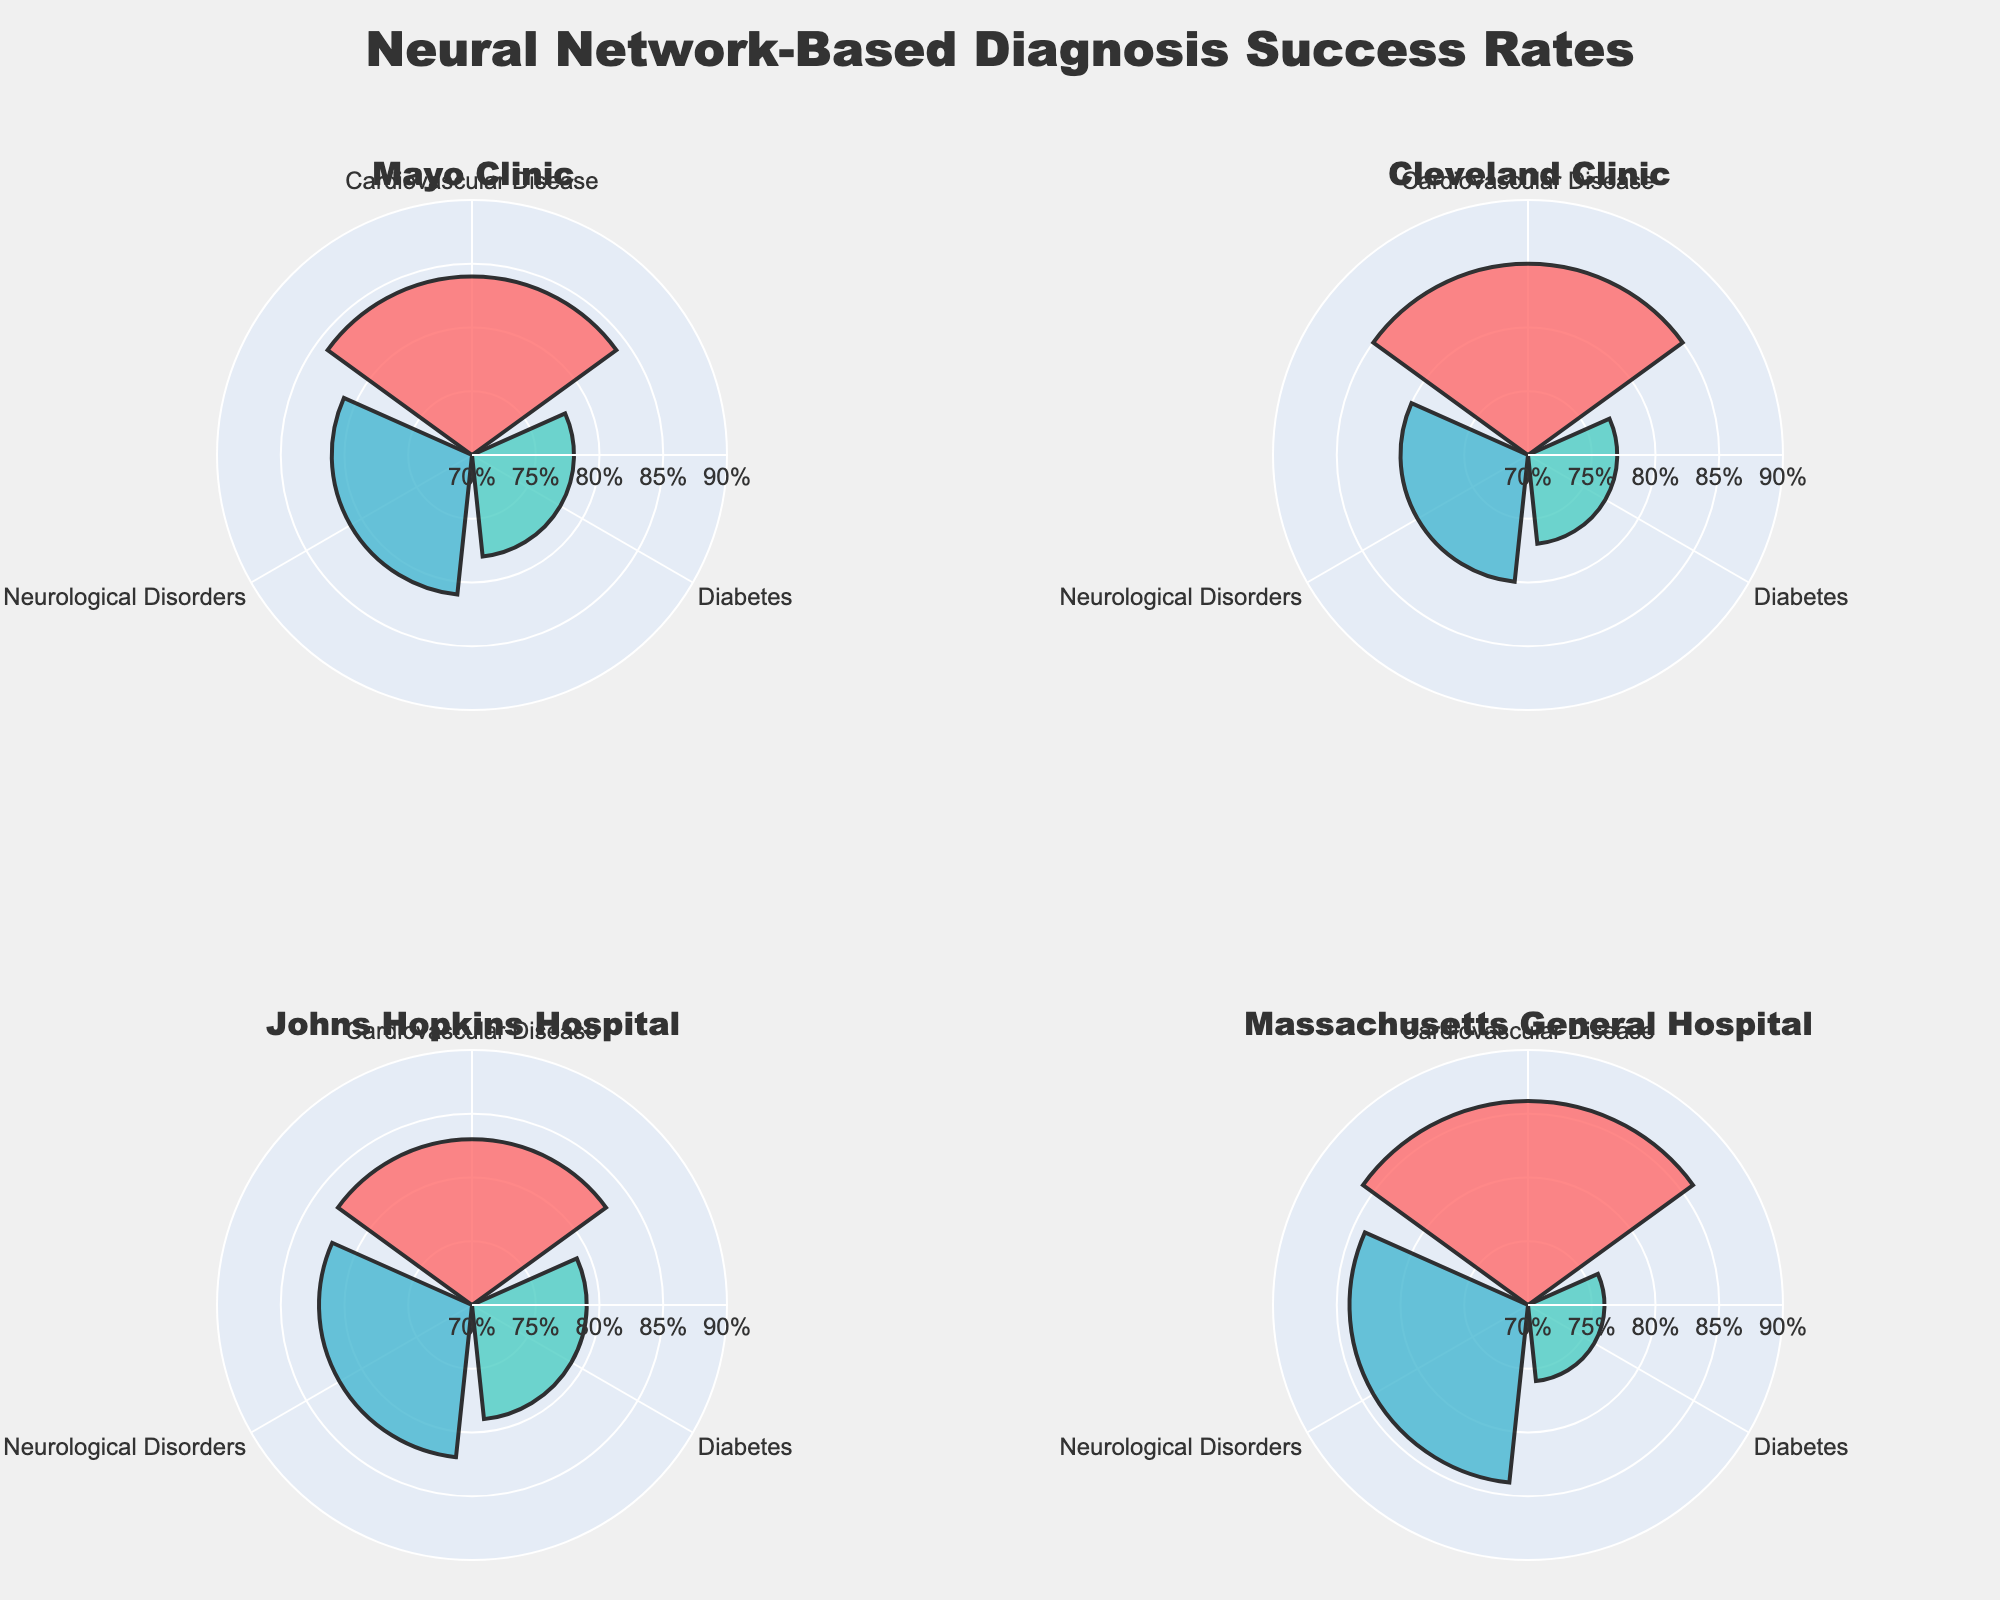What is the success rate of neural network-based diagnosis for Cardiovascular Disease at Mayo Clinic? To find the success rate, locate the Mayo Clinic subplot and see that the Cardiovascular Disease slice extends to the 84% mark on the radial axis.
Answer: 84% Which medical facility has the highest success rate for diagnosing Neurological Disorders? Compare the success rates for Neurological Disorders across all subplots and identify that Massachusetts General Hospital has the highest rate extending to 84%.
Answer: Massachusetts General Hospital Between Mayo Clinic and Cleveland Clinic, which has a higher success rate for diagnosing Diabetes, and by how much? Look at the Diabetes success rates in the subplots for Mayo Clinic and Cleveland Clinic. Mayo Clinic has a 78% success rate while Cleveland Clinic has 77%. The difference is 1%.
Answer: Mayo Clinic, by 1% What is the average success rate for Cardiovascular Disease across all medical facilities? Sum the success rates for Cardiovascular Disease across all subplots: 84%, 85%, 83%, 86%. The total is 338%. Divide by 4 to get the average: 338% / 4 = 84.5%.
Answer: 84.5% How does the success rate for Neurological Disorders at Johns Hopkins Hospital compare to that at Mayo Clinic? Compare the lengths of the Neurological Disorders slices for both Johns Hopkins Hospital (82%) and Mayo Clinic (81%). Johns Hopkins Hospital has a higher rate by 1%.
Answer: Johns Hopkins Hospital is higher by 1% For which condition is the success rate the lowest at Massachusetts General Hospital? Look at the slices for different conditions at Massachusetts General Hospital and see that Diabetes has the shortest slice, corresponding to 76%.
Answer: Diabetes What's the difference in the success rates for diagnosing Cardiovascular Disease and Diabetes at Cleveland Clinic? Subtract the success rate for Diabetes (77%) from that for Cardiovascular Disease (85%) to obtain the difference: 85% - 77% = 8%.
Answer: 8% How does the success rate for Diabetes at Johns Hopkins Hospital compare to Diabetes at Massachusetts General Hospital? Look at the Diabetes success rates for both hospitals. Johns Hopkins Hospital has a success rate of 79% and Massachusetts General Hospital has 76%. Johns Hopkins Hospital has a higher rate by 3%.
Answer: Johns Hopkins Hospital is higher by 3% 